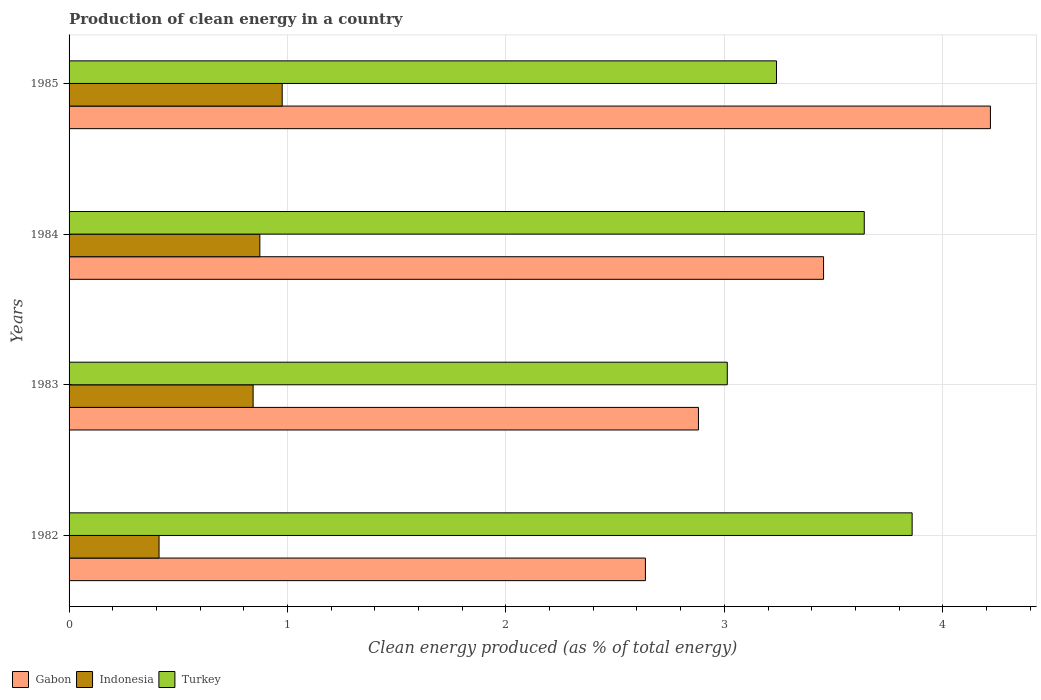How many groups of bars are there?
Ensure brevity in your answer.  4. Are the number of bars on each tick of the Y-axis equal?
Make the answer very short. Yes. How many bars are there on the 1st tick from the top?
Provide a succinct answer. 3. What is the label of the 4th group of bars from the top?
Ensure brevity in your answer.  1982. In how many cases, is the number of bars for a given year not equal to the number of legend labels?
Provide a succinct answer. 0. What is the percentage of clean energy produced in Turkey in 1982?
Make the answer very short. 3.86. Across all years, what is the maximum percentage of clean energy produced in Gabon?
Your response must be concise. 4.22. Across all years, what is the minimum percentage of clean energy produced in Indonesia?
Your answer should be very brief. 0.41. What is the total percentage of clean energy produced in Turkey in the graph?
Offer a very short reply. 13.75. What is the difference between the percentage of clean energy produced in Indonesia in 1983 and that in 1985?
Give a very brief answer. -0.13. What is the difference between the percentage of clean energy produced in Gabon in 1983 and the percentage of clean energy produced in Indonesia in 1984?
Your answer should be very brief. 2.01. What is the average percentage of clean energy produced in Indonesia per year?
Your response must be concise. 0.78. In the year 1982, what is the difference between the percentage of clean energy produced in Indonesia and percentage of clean energy produced in Gabon?
Make the answer very short. -2.23. In how many years, is the percentage of clean energy produced in Indonesia greater than 0.4 %?
Your response must be concise. 4. What is the ratio of the percentage of clean energy produced in Gabon in 1983 to that in 1984?
Provide a succinct answer. 0.83. Is the percentage of clean energy produced in Gabon in 1983 less than that in 1985?
Ensure brevity in your answer.  Yes. What is the difference between the highest and the second highest percentage of clean energy produced in Gabon?
Keep it short and to the point. 0.76. What is the difference between the highest and the lowest percentage of clean energy produced in Gabon?
Offer a very short reply. 1.58. In how many years, is the percentage of clean energy produced in Turkey greater than the average percentage of clean energy produced in Turkey taken over all years?
Keep it short and to the point. 2. What does the 1st bar from the top in 1984 represents?
Your answer should be compact. Turkey. What does the 2nd bar from the bottom in 1983 represents?
Ensure brevity in your answer.  Indonesia. How many bars are there?
Ensure brevity in your answer.  12. Does the graph contain any zero values?
Offer a very short reply. No. Where does the legend appear in the graph?
Your answer should be very brief. Bottom left. How many legend labels are there?
Offer a terse response. 3. What is the title of the graph?
Your answer should be compact. Production of clean energy in a country. Does "Spain" appear as one of the legend labels in the graph?
Your response must be concise. No. What is the label or title of the X-axis?
Make the answer very short. Clean energy produced (as % of total energy). What is the Clean energy produced (as % of total energy) of Gabon in 1982?
Your answer should be very brief. 2.64. What is the Clean energy produced (as % of total energy) of Indonesia in 1982?
Make the answer very short. 0.41. What is the Clean energy produced (as % of total energy) of Turkey in 1982?
Provide a succinct answer. 3.86. What is the Clean energy produced (as % of total energy) of Gabon in 1983?
Make the answer very short. 2.88. What is the Clean energy produced (as % of total energy) in Indonesia in 1983?
Keep it short and to the point. 0.84. What is the Clean energy produced (as % of total energy) of Turkey in 1983?
Your response must be concise. 3.01. What is the Clean energy produced (as % of total energy) in Gabon in 1984?
Your response must be concise. 3.45. What is the Clean energy produced (as % of total energy) of Indonesia in 1984?
Your answer should be very brief. 0.87. What is the Clean energy produced (as % of total energy) of Turkey in 1984?
Offer a terse response. 3.64. What is the Clean energy produced (as % of total energy) of Gabon in 1985?
Make the answer very short. 4.22. What is the Clean energy produced (as % of total energy) in Indonesia in 1985?
Offer a very short reply. 0.98. What is the Clean energy produced (as % of total energy) in Turkey in 1985?
Offer a very short reply. 3.24. Across all years, what is the maximum Clean energy produced (as % of total energy) of Gabon?
Offer a terse response. 4.22. Across all years, what is the maximum Clean energy produced (as % of total energy) in Indonesia?
Ensure brevity in your answer.  0.98. Across all years, what is the maximum Clean energy produced (as % of total energy) in Turkey?
Your answer should be compact. 3.86. Across all years, what is the minimum Clean energy produced (as % of total energy) of Gabon?
Make the answer very short. 2.64. Across all years, what is the minimum Clean energy produced (as % of total energy) of Indonesia?
Give a very brief answer. 0.41. Across all years, what is the minimum Clean energy produced (as % of total energy) of Turkey?
Ensure brevity in your answer.  3.01. What is the total Clean energy produced (as % of total energy) in Gabon in the graph?
Offer a very short reply. 13.19. What is the total Clean energy produced (as % of total energy) of Indonesia in the graph?
Keep it short and to the point. 3.1. What is the total Clean energy produced (as % of total energy) of Turkey in the graph?
Provide a short and direct response. 13.75. What is the difference between the Clean energy produced (as % of total energy) of Gabon in 1982 and that in 1983?
Provide a short and direct response. -0.24. What is the difference between the Clean energy produced (as % of total energy) of Indonesia in 1982 and that in 1983?
Offer a very short reply. -0.43. What is the difference between the Clean energy produced (as % of total energy) in Turkey in 1982 and that in 1983?
Ensure brevity in your answer.  0.85. What is the difference between the Clean energy produced (as % of total energy) in Gabon in 1982 and that in 1984?
Your answer should be compact. -0.82. What is the difference between the Clean energy produced (as % of total energy) in Indonesia in 1982 and that in 1984?
Provide a short and direct response. -0.46. What is the difference between the Clean energy produced (as % of total energy) of Turkey in 1982 and that in 1984?
Provide a succinct answer. 0.22. What is the difference between the Clean energy produced (as % of total energy) of Gabon in 1982 and that in 1985?
Offer a terse response. -1.58. What is the difference between the Clean energy produced (as % of total energy) of Indonesia in 1982 and that in 1985?
Offer a very short reply. -0.56. What is the difference between the Clean energy produced (as % of total energy) of Turkey in 1982 and that in 1985?
Ensure brevity in your answer.  0.62. What is the difference between the Clean energy produced (as % of total energy) in Gabon in 1983 and that in 1984?
Ensure brevity in your answer.  -0.57. What is the difference between the Clean energy produced (as % of total energy) in Indonesia in 1983 and that in 1984?
Offer a terse response. -0.03. What is the difference between the Clean energy produced (as % of total energy) in Turkey in 1983 and that in 1984?
Your response must be concise. -0.63. What is the difference between the Clean energy produced (as % of total energy) in Gabon in 1983 and that in 1985?
Make the answer very short. -1.34. What is the difference between the Clean energy produced (as % of total energy) in Indonesia in 1983 and that in 1985?
Provide a succinct answer. -0.13. What is the difference between the Clean energy produced (as % of total energy) in Turkey in 1983 and that in 1985?
Your answer should be compact. -0.23. What is the difference between the Clean energy produced (as % of total energy) of Gabon in 1984 and that in 1985?
Offer a terse response. -0.76. What is the difference between the Clean energy produced (as % of total energy) of Indonesia in 1984 and that in 1985?
Keep it short and to the point. -0.1. What is the difference between the Clean energy produced (as % of total energy) in Turkey in 1984 and that in 1985?
Offer a terse response. 0.4. What is the difference between the Clean energy produced (as % of total energy) in Gabon in 1982 and the Clean energy produced (as % of total energy) in Indonesia in 1983?
Provide a succinct answer. 1.8. What is the difference between the Clean energy produced (as % of total energy) in Gabon in 1982 and the Clean energy produced (as % of total energy) in Turkey in 1983?
Provide a succinct answer. -0.37. What is the difference between the Clean energy produced (as % of total energy) in Indonesia in 1982 and the Clean energy produced (as % of total energy) in Turkey in 1983?
Ensure brevity in your answer.  -2.6. What is the difference between the Clean energy produced (as % of total energy) of Gabon in 1982 and the Clean energy produced (as % of total energy) of Indonesia in 1984?
Your answer should be compact. 1.77. What is the difference between the Clean energy produced (as % of total energy) in Gabon in 1982 and the Clean energy produced (as % of total energy) in Turkey in 1984?
Make the answer very short. -1. What is the difference between the Clean energy produced (as % of total energy) of Indonesia in 1982 and the Clean energy produced (as % of total energy) of Turkey in 1984?
Your answer should be compact. -3.23. What is the difference between the Clean energy produced (as % of total energy) in Gabon in 1982 and the Clean energy produced (as % of total energy) in Indonesia in 1985?
Keep it short and to the point. 1.66. What is the difference between the Clean energy produced (as % of total energy) of Gabon in 1982 and the Clean energy produced (as % of total energy) of Turkey in 1985?
Your answer should be very brief. -0.6. What is the difference between the Clean energy produced (as % of total energy) in Indonesia in 1982 and the Clean energy produced (as % of total energy) in Turkey in 1985?
Your answer should be compact. -2.83. What is the difference between the Clean energy produced (as % of total energy) in Gabon in 1983 and the Clean energy produced (as % of total energy) in Indonesia in 1984?
Offer a terse response. 2.01. What is the difference between the Clean energy produced (as % of total energy) of Gabon in 1983 and the Clean energy produced (as % of total energy) of Turkey in 1984?
Make the answer very short. -0.76. What is the difference between the Clean energy produced (as % of total energy) of Indonesia in 1983 and the Clean energy produced (as % of total energy) of Turkey in 1984?
Give a very brief answer. -2.8. What is the difference between the Clean energy produced (as % of total energy) in Gabon in 1983 and the Clean energy produced (as % of total energy) in Indonesia in 1985?
Ensure brevity in your answer.  1.91. What is the difference between the Clean energy produced (as % of total energy) in Gabon in 1983 and the Clean energy produced (as % of total energy) in Turkey in 1985?
Offer a terse response. -0.36. What is the difference between the Clean energy produced (as % of total energy) in Indonesia in 1983 and the Clean energy produced (as % of total energy) in Turkey in 1985?
Your answer should be very brief. -2.4. What is the difference between the Clean energy produced (as % of total energy) in Gabon in 1984 and the Clean energy produced (as % of total energy) in Indonesia in 1985?
Your answer should be very brief. 2.48. What is the difference between the Clean energy produced (as % of total energy) of Gabon in 1984 and the Clean energy produced (as % of total energy) of Turkey in 1985?
Offer a terse response. 0.22. What is the difference between the Clean energy produced (as % of total energy) in Indonesia in 1984 and the Clean energy produced (as % of total energy) in Turkey in 1985?
Make the answer very short. -2.37. What is the average Clean energy produced (as % of total energy) in Gabon per year?
Keep it short and to the point. 3.3. What is the average Clean energy produced (as % of total energy) of Indonesia per year?
Your response must be concise. 0.78. What is the average Clean energy produced (as % of total energy) of Turkey per year?
Make the answer very short. 3.44. In the year 1982, what is the difference between the Clean energy produced (as % of total energy) in Gabon and Clean energy produced (as % of total energy) in Indonesia?
Make the answer very short. 2.23. In the year 1982, what is the difference between the Clean energy produced (as % of total energy) of Gabon and Clean energy produced (as % of total energy) of Turkey?
Your answer should be compact. -1.22. In the year 1982, what is the difference between the Clean energy produced (as % of total energy) in Indonesia and Clean energy produced (as % of total energy) in Turkey?
Provide a short and direct response. -3.45. In the year 1983, what is the difference between the Clean energy produced (as % of total energy) in Gabon and Clean energy produced (as % of total energy) in Indonesia?
Your answer should be compact. 2.04. In the year 1983, what is the difference between the Clean energy produced (as % of total energy) in Gabon and Clean energy produced (as % of total energy) in Turkey?
Offer a very short reply. -0.13. In the year 1983, what is the difference between the Clean energy produced (as % of total energy) in Indonesia and Clean energy produced (as % of total energy) in Turkey?
Give a very brief answer. -2.17. In the year 1984, what is the difference between the Clean energy produced (as % of total energy) of Gabon and Clean energy produced (as % of total energy) of Indonesia?
Provide a succinct answer. 2.58. In the year 1984, what is the difference between the Clean energy produced (as % of total energy) of Gabon and Clean energy produced (as % of total energy) of Turkey?
Provide a succinct answer. -0.19. In the year 1984, what is the difference between the Clean energy produced (as % of total energy) in Indonesia and Clean energy produced (as % of total energy) in Turkey?
Keep it short and to the point. -2.77. In the year 1985, what is the difference between the Clean energy produced (as % of total energy) of Gabon and Clean energy produced (as % of total energy) of Indonesia?
Provide a succinct answer. 3.24. In the year 1985, what is the difference between the Clean energy produced (as % of total energy) in Gabon and Clean energy produced (as % of total energy) in Turkey?
Your response must be concise. 0.98. In the year 1985, what is the difference between the Clean energy produced (as % of total energy) in Indonesia and Clean energy produced (as % of total energy) in Turkey?
Provide a short and direct response. -2.26. What is the ratio of the Clean energy produced (as % of total energy) of Gabon in 1982 to that in 1983?
Provide a short and direct response. 0.92. What is the ratio of the Clean energy produced (as % of total energy) in Indonesia in 1982 to that in 1983?
Your response must be concise. 0.49. What is the ratio of the Clean energy produced (as % of total energy) of Turkey in 1982 to that in 1983?
Make the answer very short. 1.28. What is the ratio of the Clean energy produced (as % of total energy) of Gabon in 1982 to that in 1984?
Ensure brevity in your answer.  0.76. What is the ratio of the Clean energy produced (as % of total energy) of Indonesia in 1982 to that in 1984?
Provide a succinct answer. 0.47. What is the ratio of the Clean energy produced (as % of total energy) in Turkey in 1982 to that in 1984?
Keep it short and to the point. 1.06. What is the ratio of the Clean energy produced (as % of total energy) in Gabon in 1982 to that in 1985?
Your answer should be compact. 0.63. What is the ratio of the Clean energy produced (as % of total energy) of Indonesia in 1982 to that in 1985?
Provide a succinct answer. 0.42. What is the ratio of the Clean energy produced (as % of total energy) in Turkey in 1982 to that in 1985?
Offer a very short reply. 1.19. What is the ratio of the Clean energy produced (as % of total energy) of Gabon in 1983 to that in 1984?
Your answer should be compact. 0.83. What is the ratio of the Clean energy produced (as % of total energy) of Indonesia in 1983 to that in 1984?
Ensure brevity in your answer.  0.96. What is the ratio of the Clean energy produced (as % of total energy) of Turkey in 1983 to that in 1984?
Make the answer very short. 0.83. What is the ratio of the Clean energy produced (as % of total energy) in Gabon in 1983 to that in 1985?
Make the answer very short. 0.68. What is the ratio of the Clean energy produced (as % of total energy) in Indonesia in 1983 to that in 1985?
Provide a short and direct response. 0.86. What is the ratio of the Clean energy produced (as % of total energy) in Turkey in 1983 to that in 1985?
Offer a terse response. 0.93. What is the ratio of the Clean energy produced (as % of total energy) in Gabon in 1984 to that in 1985?
Provide a short and direct response. 0.82. What is the ratio of the Clean energy produced (as % of total energy) in Indonesia in 1984 to that in 1985?
Offer a terse response. 0.9. What is the ratio of the Clean energy produced (as % of total energy) in Turkey in 1984 to that in 1985?
Keep it short and to the point. 1.12. What is the difference between the highest and the second highest Clean energy produced (as % of total energy) of Gabon?
Your answer should be compact. 0.76. What is the difference between the highest and the second highest Clean energy produced (as % of total energy) of Indonesia?
Your answer should be compact. 0.1. What is the difference between the highest and the second highest Clean energy produced (as % of total energy) of Turkey?
Make the answer very short. 0.22. What is the difference between the highest and the lowest Clean energy produced (as % of total energy) in Gabon?
Offer a very short reply. 1.58. What is the difference between the highest and the lowest Clean energy produced (as % of total energy) in Indonesia?
Your answer should be very brief. 0.56. What is the difference between the highest and the lowest Clean energy produced (as % of total energy) of Turkey?
Offer a terse response. 0.85. 